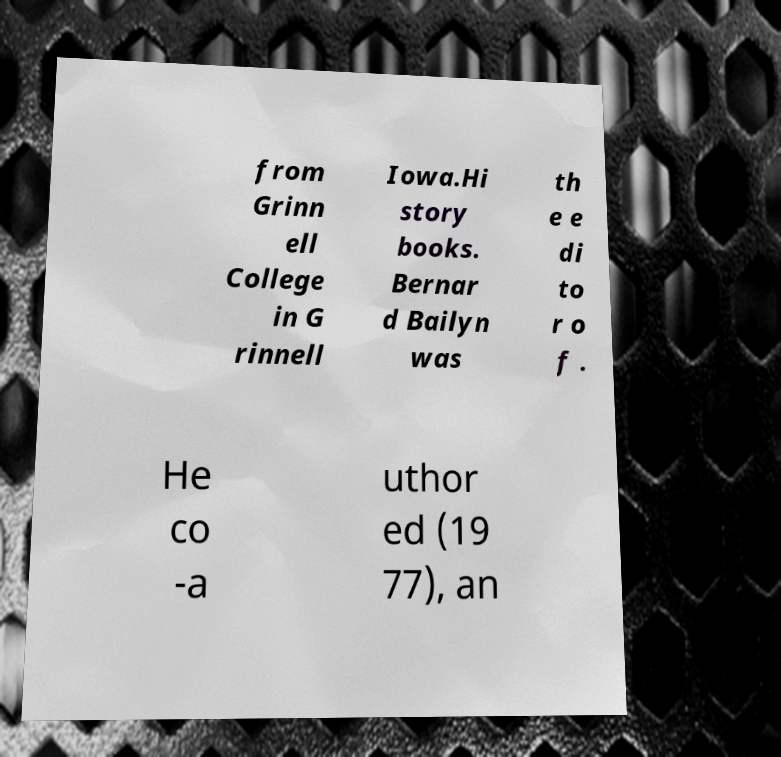Please read and relay the text visible in this image. What does it say? from Grinn ell College in G rinnell Iowa.Hi story books. Bernar d Bailyn was th e e di to r o f . He co -a uthor ed (19 77), an 